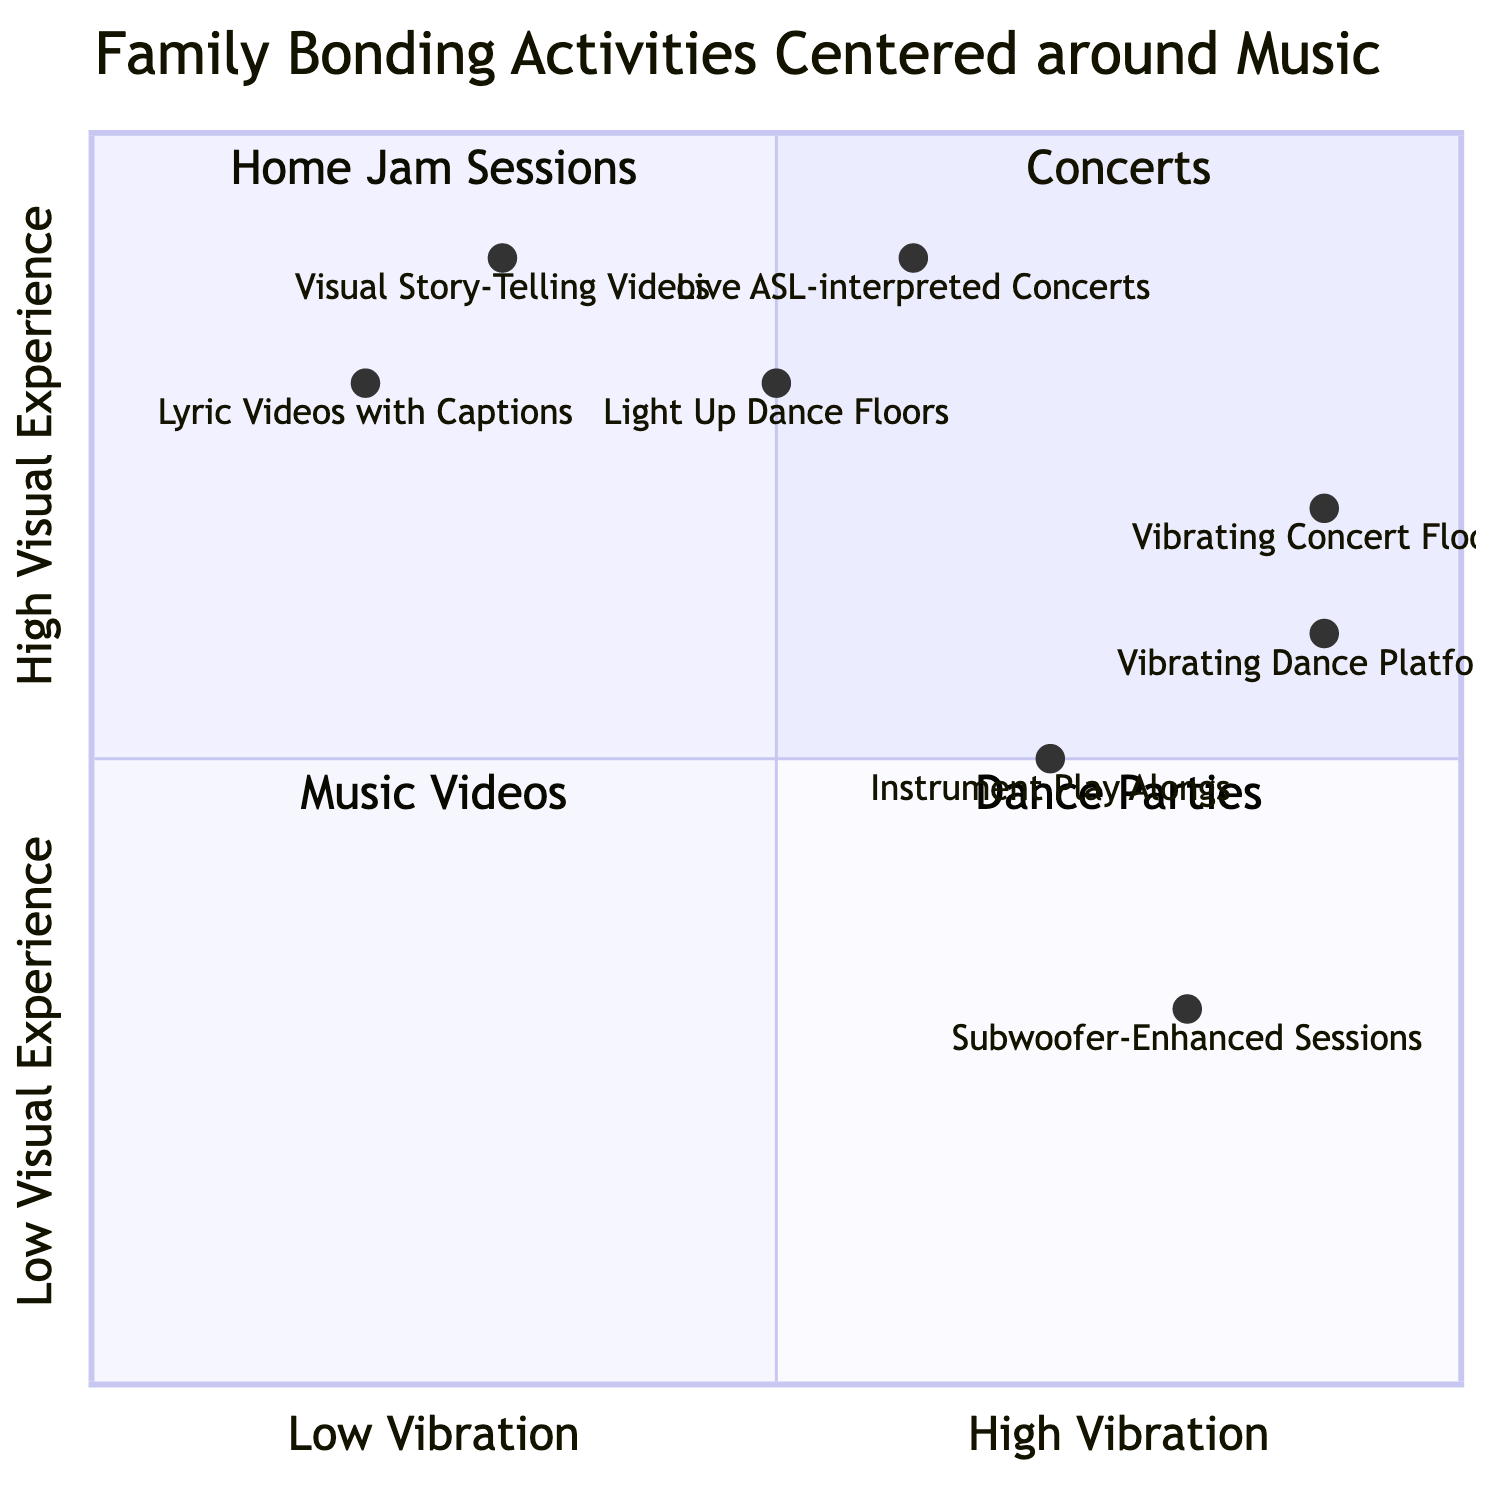What is the y-axis label? The y-axis represents the level of visual experience in the diagram, which ranges from low to high.
Answer: High Visual Experience Which quadrant contains "Vibrating Concert Floors"? "Vibrating Concert Floors" is located in the Concerts quadrant, as listed in the elements of that specific quadrant.
Answer: Concerts How many elements are in the "Home Jam Sessions" quadrant? There are two elements listed in the "Home Jam Sessions" quadrant, which are "Subwoofer-Enhanced Sessions" and "Instrument Play Alongs."
Answer: 2 What is the vibration level of "Lyric Videos with Captions"? The vibration level for "Lyric Videos with Captions" is represented by the coordinates [0.2, 0.8], indicating a low level of vibration.
Answer: 0.2 Which element has the highest vibration level? "Vibrating Dance Platforms" has the highest vibration level at 0.9, as per its coordinates [0.9, 0.6].
Answer: Vibrating Dance Platforms Which quadrant has elements with the lowest average visual experience? The "Home Jam Sessions" quadrant has the lowest average visual experience, as its elements have lower y-axis values compared to other quadrants.
Answer: Home Jam Sessions What is the visual experience score for "Instrument Play Alongs"? The visual experience score for "Instrument Play Alongs" is indicated by its y-coordinate, which is 0.5.
Answer: 0.5 Which element is closest to the high vibration end on the x-axis? "Vibrating Dance Platforms," with a vibration level of 0.9, is closest to the high vibration end on the x-axis.
Answer: Vibrating Dance Platforms 